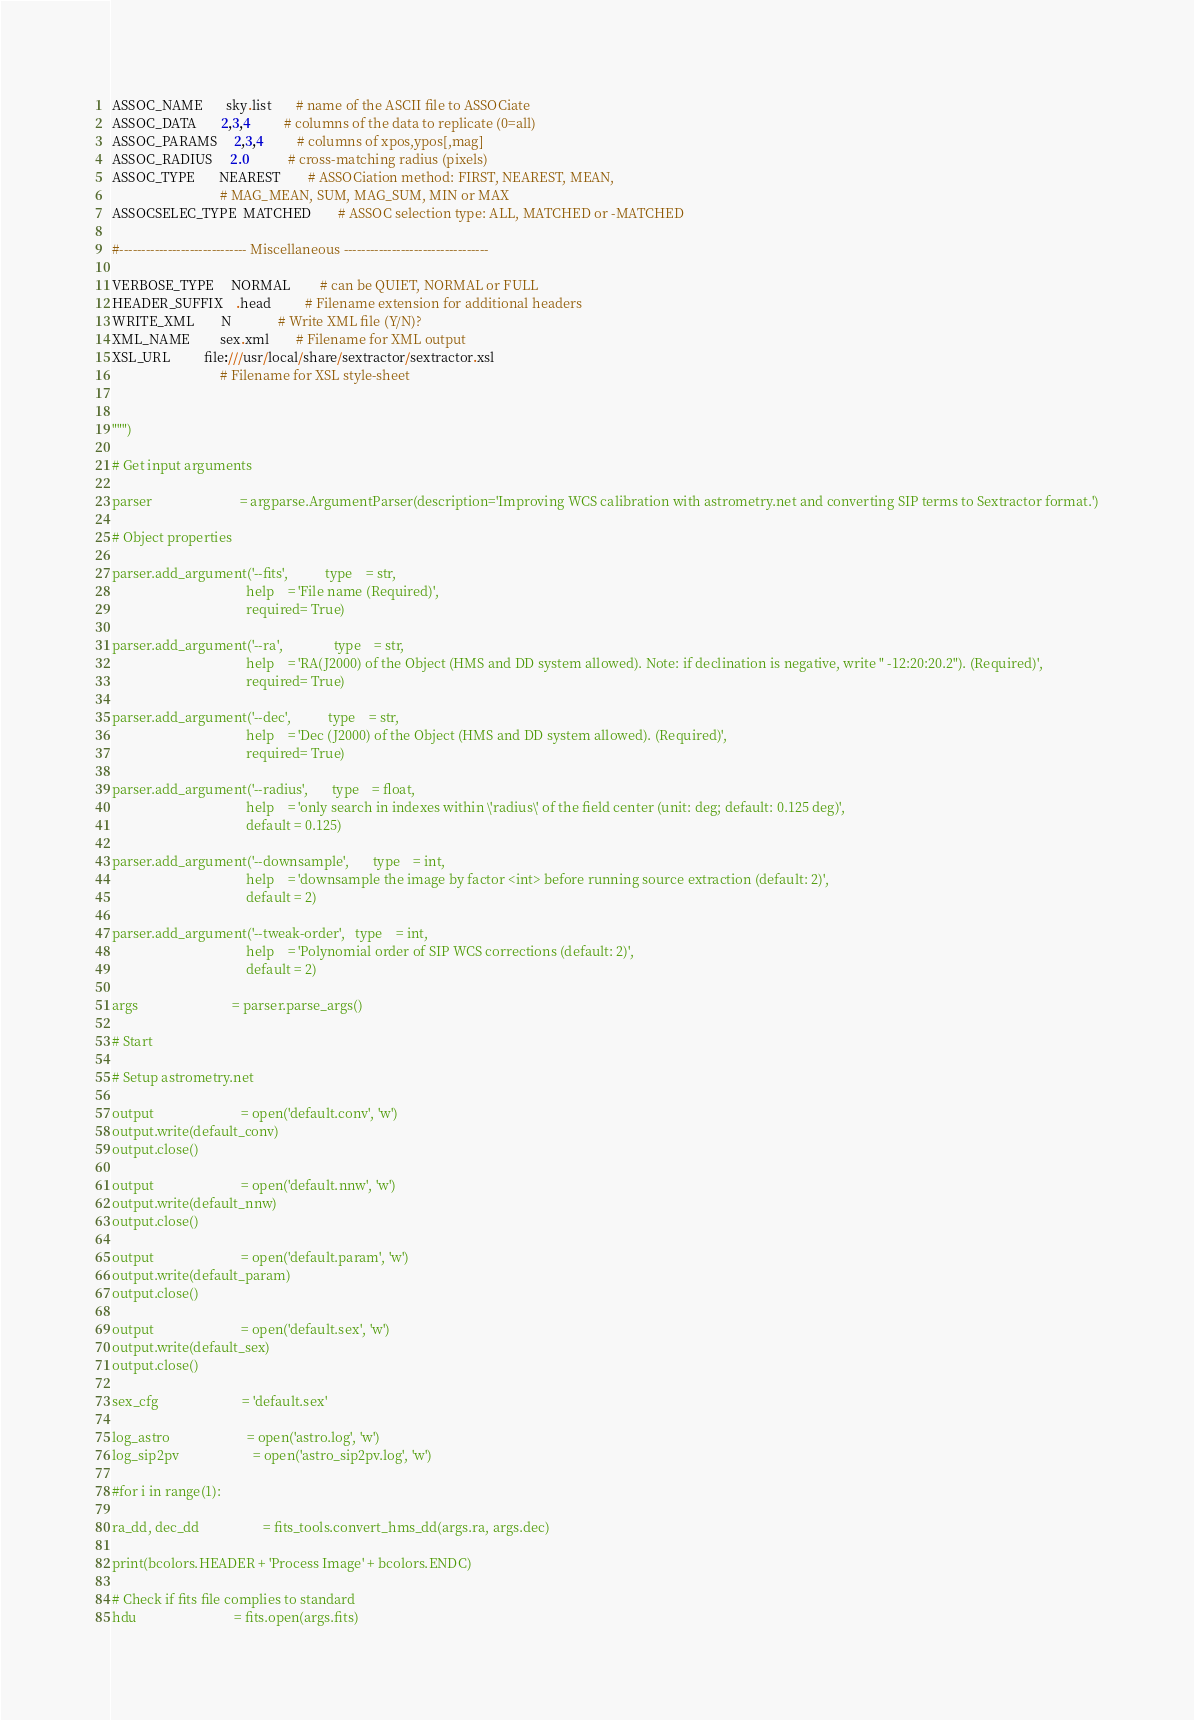Convert code to text. <code><loc_0><loc_0><loc_500><loc_500><_Python_>
ASSOC_NAME       sky.list       # name of the ASCII file to ASSOCiate
ASSOC_DATA       2,3,4          # columns of the data to replicate (0=all)
ASSOC_PARAMS     2,3,4          # columns of xpos,ypos[,mag]
ASSOC_RADIUS     2.0            # cross-matching radius (pixels)
ASSOC_TYPE       NEAREST        # ASSOCiation method: FIRST, NEAREST, MEAN,
                                # MAG_MEAN, SUM, MAG_SUM, MIN or MAX
ASSOCSELEC_TYPE  MATCHED        # ASSOC selection type: ALL, MATCHED or -MATCHED

#----------------------------- Miscellaneous ---------------------------------
 
VERBOSE_TYPE     NORMAL         # can be QUIET, NORMAL or FULL
HEADER_SUFFIX    .head          # Filename extension for additional headers
WRITE_XML        N              # Write XML file (Y/N)?
XML_NAME         sex.xml        # Filename for XML output
XSL_URL          file:///usr/local/share/sextractor/sextractor.xsl
                                # Filename for XSL style-sheet


""")

# Get input arguments

parser							= argparse.ArgumentParser(description='Improving WCS calibration with astrometry.net and converting SIP terms to Sextractor format.')

# Object properties

parser.add_argument('--fits',			type	= str,
										help	= 'File name (Required)',
										required= True)

parser.add_argument('--ra',				type	= str,
										help	= 'RA(J2000) of the Object (HMS and DD system allowed). Note: if declination is negative, write " -12:20:20.2"). (Required)',
										required= True)

parser.add_argument('--dec', 			type	= str,
										help	= 'Dec (J2000) of the Object (HMS and DD system allowed). (Required)',
										required= True)

parser.add_argument('--radius', 		type	= float,
										help	= 'only search in indexes within \'radius\' of the field center (unit: deg; default: 0.125 deg)',
										default = 0.125)

parser.add_argument('--downsample',		type	= int,
										help	= 'downsample the image by factor <int> before running source extraction (default: 2)',
										default = 2)

parser.add_argument('--tweak-order',	type	= int,
										help	= 'Polynomial order of SIP WCS corrections (default: 2)',
										default = 2)

args							= parser.parse_args()

# Start

# Setup astrometry.net

output 							= open('default.conv', 'w')
output.write(default_conv)
output.close()

output 							= open('default.nnw', 'w')
output.write(default_nnw)
output.close()

output 							= open('default.param', 'w')
output.write(default_param)
output.close()

output 							= open('default.sex', 'w')
output.write(default_sex)
output.close()

sex_cfg							= 'default.sex'

log_astro						= open('astro.log', 'w')
log_sip2pv						= open('astro_sip2pv.log', 'w')

#for i in range(1):

ra_dd, dec_dd					= fits_tools.convert_hms_dd(args.ra, args.dec)

print(bcolors.HEADER + 'Process Image' + bcolors.ENDC)

# Check if fits file complies to standard
hdu								= fits.open(args.fits)</code> 